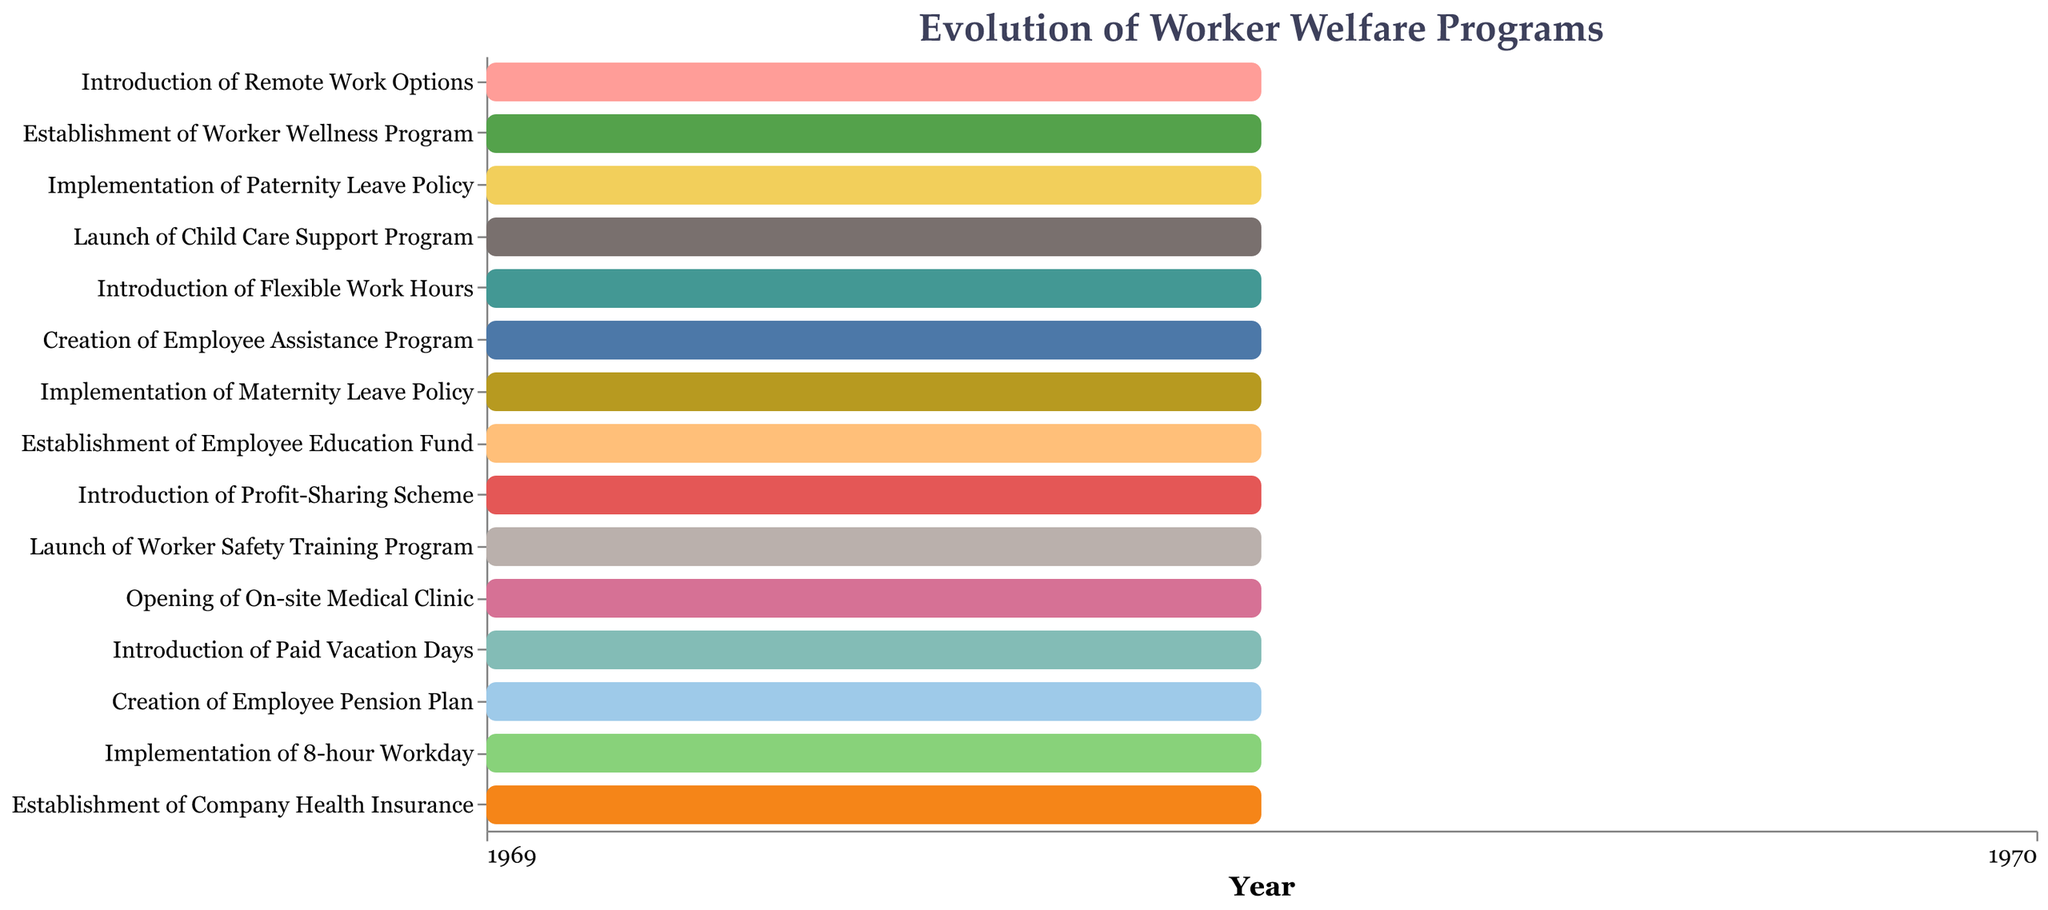How many worker welfare programs were implemented before 1950? To determine the number of programs implemented before 1950, we look for tasks with their "End" dates before 1950. The tasks that qualify are "Establishment of Company Health Insurance" (1925), "Implementation of 8-hour Workday" (1924), "Creation of Employee Pension Plan" (1932), "Introduction of Paid Vacation Days" (1936), and "Opening of On-site Medical Clinic" (1942). This totals to 5 programs.
Answer: 5 Which worker welfare program took the longest to implement and how long did it take? To find the program that took the longest to implement, we calculate the duration for each task by subtracting the "Start" year from the "End" year and look for the maximum value. "Opening of On-site Medical Clinic" took from 1938 to 1942, which is 4 years.
Answer: Opening of On-site Medical Clinic, 4 years What was the last worker welfare program implemented in the 20th century? To determine the last program implemented in the 20th century, we identify the tasks with "End" dates in the 20th century and find the latest one. "Introduction of Remote Work Options" ended in 2000, which is technically in the 20th century.
Answer: Introduction of Remote Work Options Compare the duration of the "Implementation of 8-hour Workday" and "Introduction of Paid Vacation Days". Which one took longer? Calculate the duration for both: The "Implementation of 8-hour Workday" (1923-1924) took 1 year, and the "Introduction of Paid Vacation Days" (1935-1936) also took 1 year. Since both are equal, neither took longer.
Answer: Neither How many programs took exactly 2 years to implement? We calculate the duration for each task and count how many have a duration of exactly 2 years. The programs are "Implementation of Maternity Leave Policy" (1960-1962), "Launch of Worker Safety Training Program" (1945-1947), "Introduction of Profit-Sharing Scheme" (1950-1952). This totals to 3 programs.
Answer: 3 Which decade saw the most worker welfare programs being implemented? To find the decade with the most implementations, we group the tasks by their "End" years into decades and count the tasks in each group. The 1980s have the most: "Launch of Child Care Support Program" (1983), "Implementation of Paternity Leave Policy" (1986). This totals to 2 programs ending in the 1980s.
Answer: 1980s Which worker welfare program was implemented first? To determine which program was implemented first, look for the task with the earliest "End" date. "Establishment of Company Health Insurance" ended in 1925.
Answer: Establishment of Company Health Insurance What is the total duration of all worker welfare programs? To calculate the total duration, sum the durations of all tasks. Calculation: (1925-1920) + (1924-1923) + (1932-1928) + (1936-1935) + (1942-1938) + (1947-1945) + (1952-1950) + (1958-1955) + (1962-1960) + (1968-1965) + (1977-1975) + (1983-1980) + (1986-1985) + (1993-1990) + (2000-1998) = 62 years.
Answer: 62 years Which program was implemented immediately after "Establishment of Company Health Insurance"? To determine the program implemented right after "Establishment of Company Health Insurance", we look for the program with the earliest "End" date after 1925. This is "Implementation of 8-hour Workday" (1924), but since it ends before 1925, we look further for "Creation of Employee Pension Plan" which ends in 1932.
Answer: Creation of Employee Pension Plan 